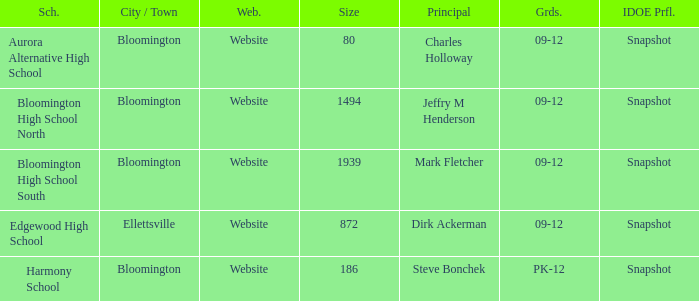Who's the principal of Edgewood High School?/ Dirk Ackerman. 